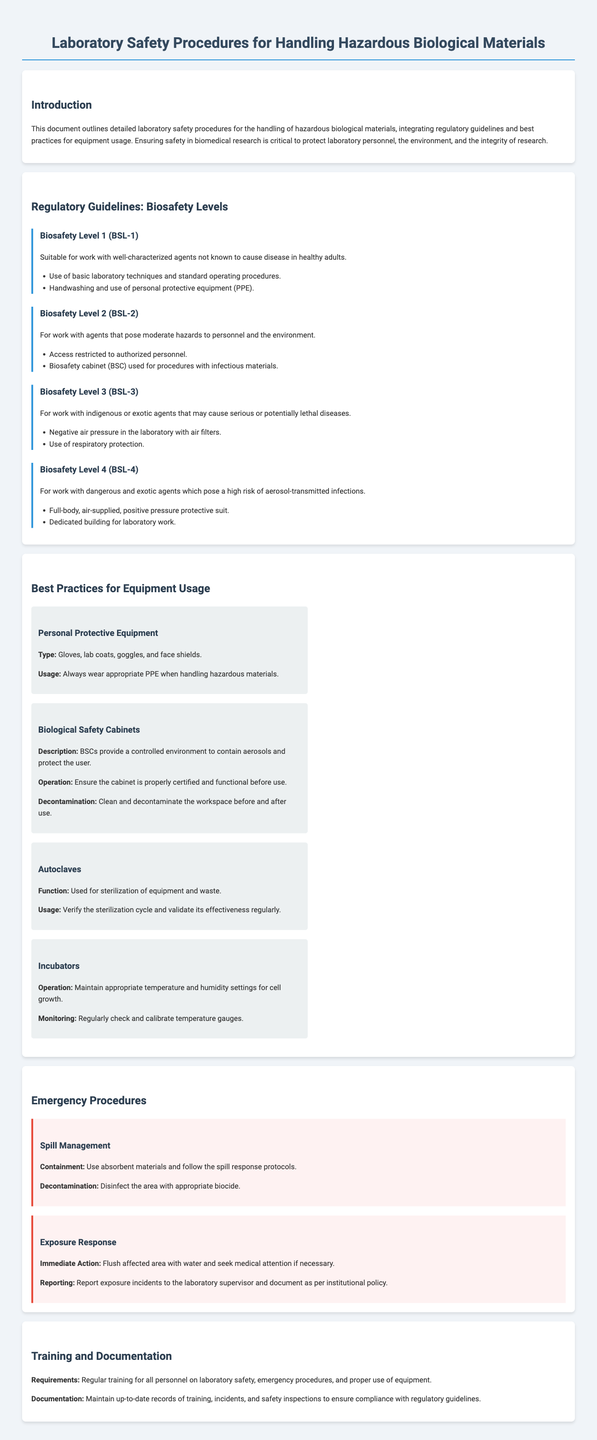What does BSL-1 indicate? BSL-1 is defined as suitable for work with well-characterized agents not known to cause disease in healthy adults.
Answer: well-characterized agents What type of protective suit is required for BSL-4? The document states that a full-body air-supplied positive pressure protective suit is required for BSL-4.
Answer: full-body, air-supplied, positive pressure protective suit What is the function of autoclaves? Autoclaves are used for the sterilization of equipment and waste according to the document.
Answer: sterilization How should biological safety cabinets be operated? The document specifies that the cabinet must be properly certified and functional before use.
Answer: properly certified and functional What does the spill management section advise for containment? The document advises using absorbent materials and following the spill response protocols for containment.
Answer: absorbent materials What is the immediate action for exposure response? The document states that the immediate action is to flush the affected area with water.
Answer: flush with water What is required for personnel training? Regular training for all personnel on laboratory safety is required as per the document.
Answer: Regular training How many Biosafety Levels are outlined in the document? The document outlines four Biosafety Levels: BSL-1, BSL-2, BSL-3, and BSL-4.
Answer: four What is essential for equipment usage according to best practices? The document highlights the usage of personal protective equipment as essential for equipment usage.
Answer: personal protective equipment 